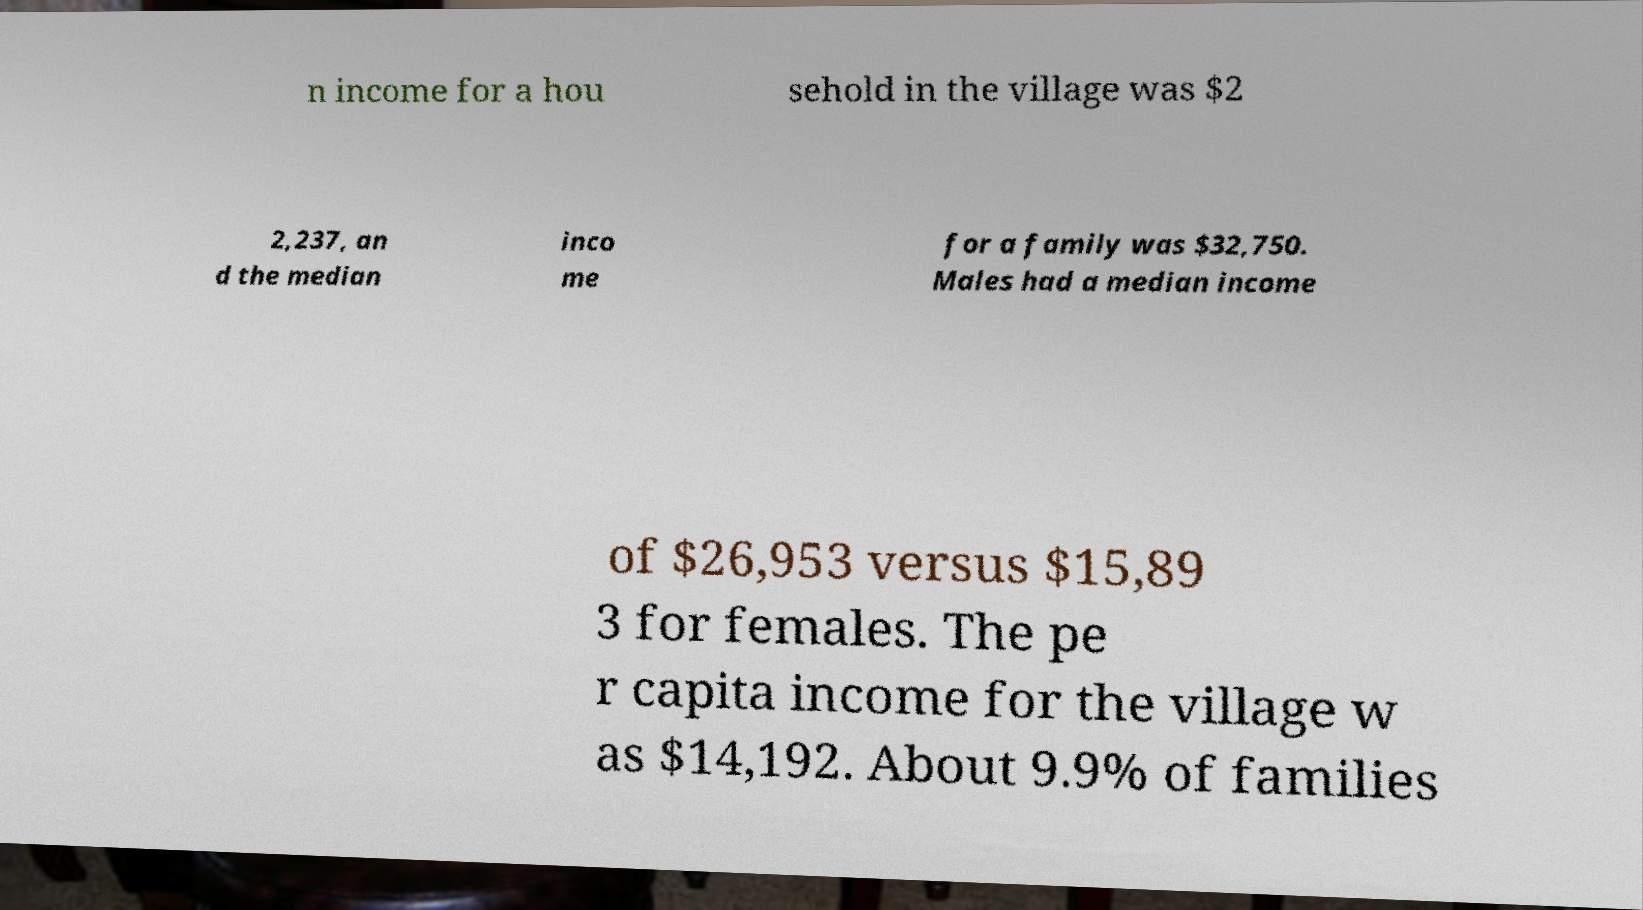Please identify and transcribe the text found in this image. n income for a hou sehold in the village was $2 2,237, an d the median inco me for a family was $32,750. Males had a median income of $26,953 versus $15,89 3 for females. The pe r capita income for the village w as $14,192. About 9.9% of families 